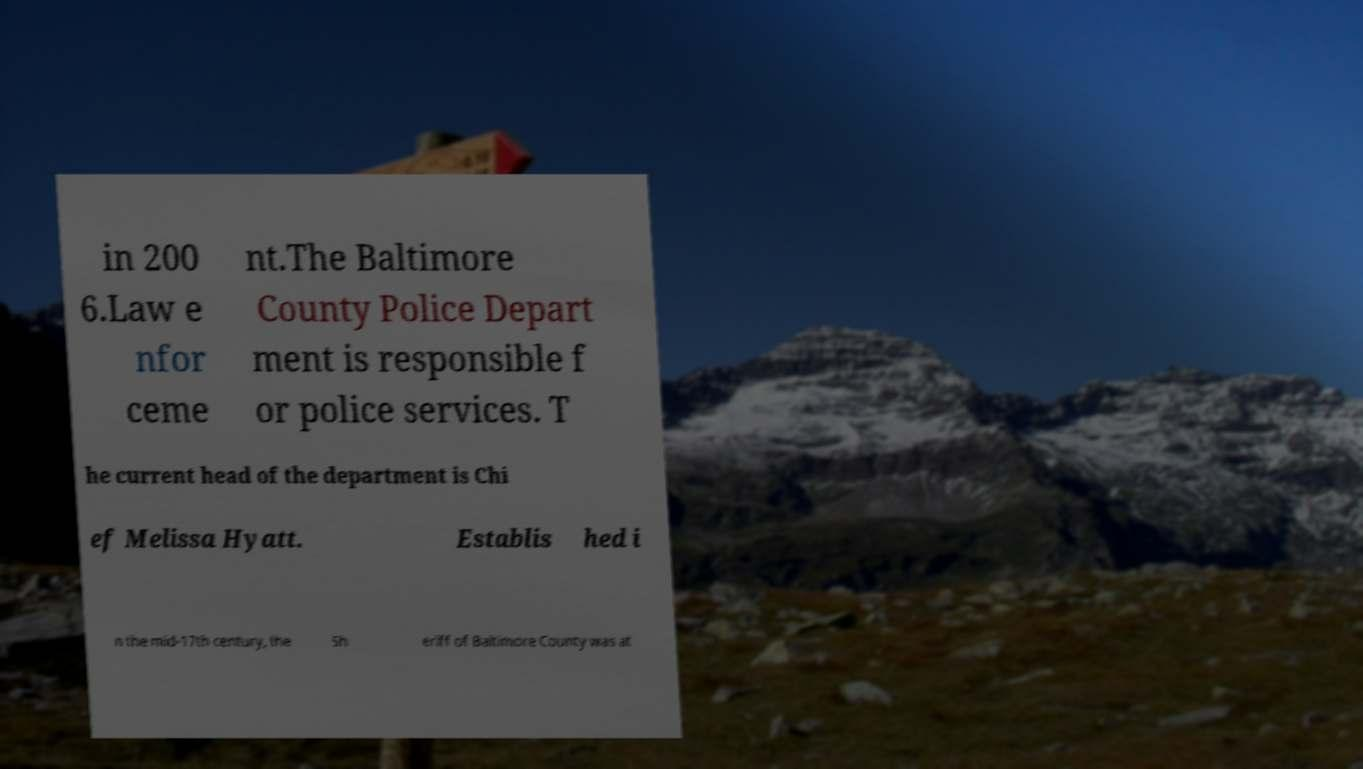Can you read and provide the text displayed in the image?This photo seems to have some interesting text. Can you extract and type it out for me? in 200 6.Law e nfor ceme nt.The Baltimore County Police Depart ment is responsible f or police services. T he current head of the department is Chi ef Melissa Hyatt. Establis hed i n the mid-17th century, the Sh eriff of Baltimore County was at 